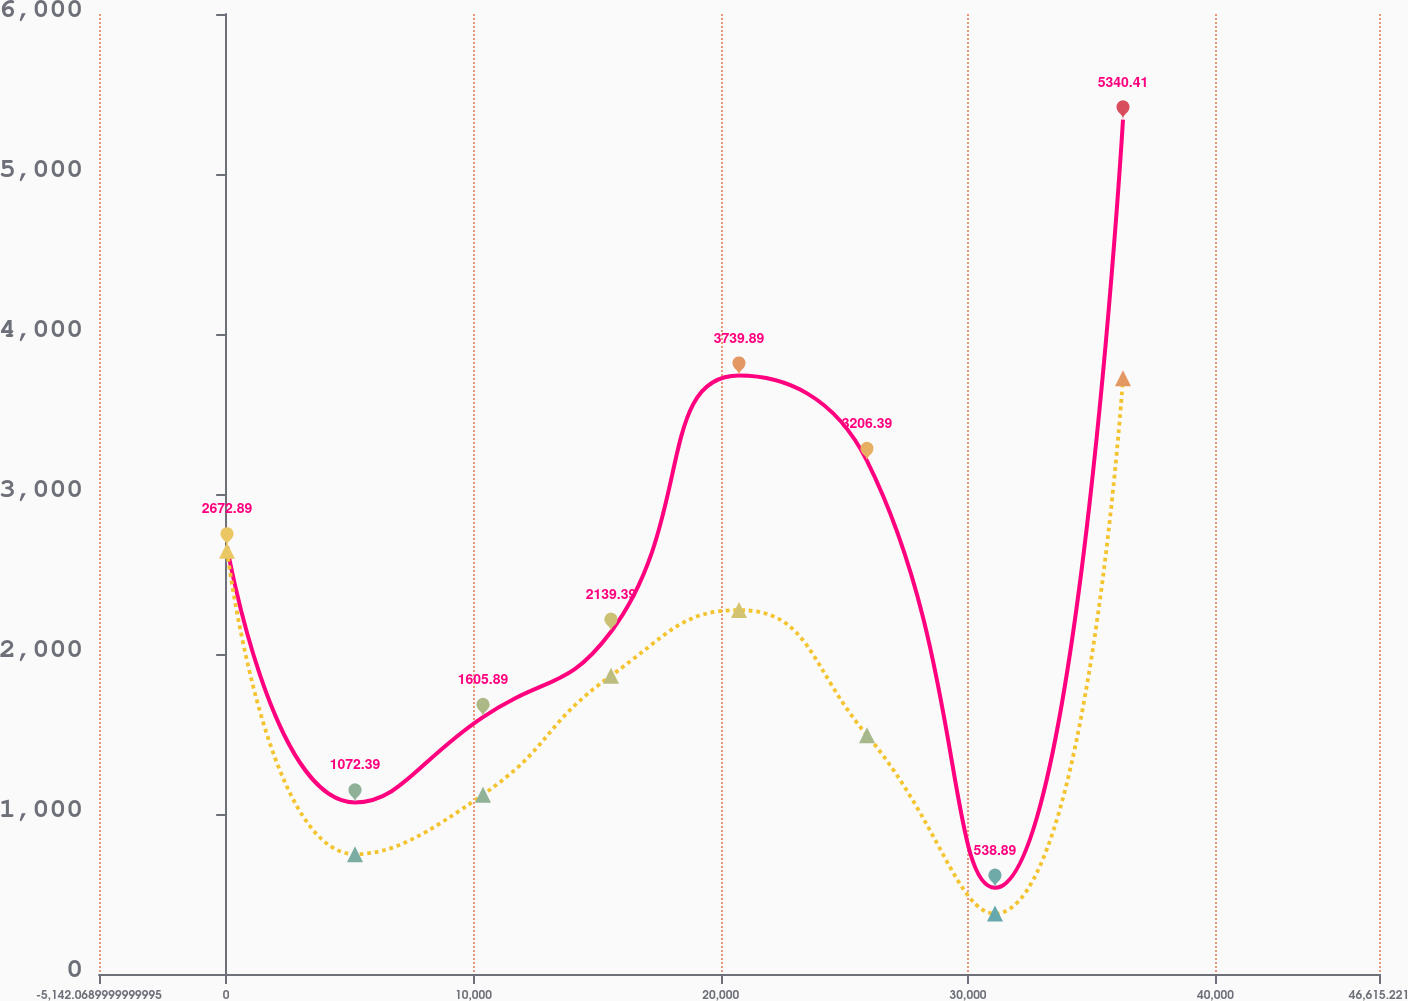Convert chart. <chart><loc_0><loc_0><loc_500><loc_500><line_chart><ecel><fcel>Home Equity December 31,<fcel>One- to Four-Family December 31,<nl><fcel>33.66<fcel>2672.89<fcel>2646.07<nl><fcel>5209.39<fcel>1072.39<fcel>749.17<nl><fcel>10385.1<fcel>1605.89<fcel>1120.91<nl><fcel>15560.9<fcel>2139.39<fcel>1864.39<nl><fcel>20736.6<fcel>3739.89<fcel>2274.33<nl><fcel>25912.3<fcel>3206.39<fcel>1492.65<nl><fcel>31088<fcel>538.89<fcel>377.43<nl><fcel>36263.8<fcel>5340.41<fcel>3723.13<nl><fcel>51790.9<fcel>5.39<fcel>5.69<nl></chart> 